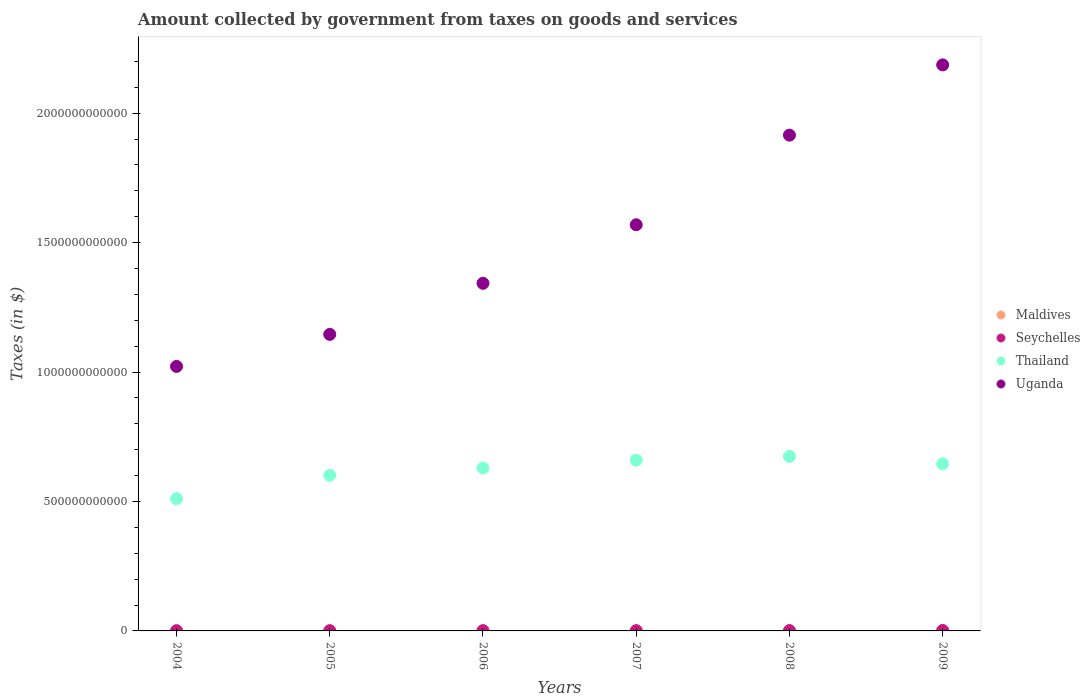Is the number of dotlines equal to the number of legend labels?
Your answer should be compact. Yes. What is the amount collected by government from taxes on goods and services in Seychelles in 2009?
Give a very brief answer. 1.66e+09. Across all years, what is the maximum amount collected by government from taxes on goods and services in Uganda?
Keep it short and to the point. 2.19e+12. Across all years, what is the minimum amount collected by government from taxes on goods and services in Uganda?
Offer a terse response. 1.02e+12. In which year was the amount collected by government from taxes on goods and services in Seychelles maximum?
Offer a terse response. 2009. In which year was the amount collected by government from taxes on goods and services in Seychelles minimum?
Offer a terse response. 2004. What is the total amount collected by government from taxes on goods and services in Uganda in the graph?
Provide a short and direct response. 9.18e+12. What is the difference between the amount collected by government from taxes on goods and services in Maldives in 2004 and that in 2008?
Keep it short and to the point. -1.87e+08. What is the difference between the amount collected by government from taxes on goods and services in Uganda in 2006 and the amount collected by government from taxes on goods and services in Thailand in 2009?
Offer a terse response. 6.97e+11. What is the average amount collected by government from taxes on goods and services in Uganda per year?
Offer a terse response. 1.53e+12. In the year 2006, what is the difference between the amount collected by government from taxes on goods and services in Seychelles and amount collected by government from taxes on goods and services in Thailand?
Offer a terse response. -6.29e+11. What is the ratio of the amount collected by government from taxes on goods and services in Maldives in 2005 to that in 2008?
Your answer should be very brief. 0.61. Is the amount collected by government from taxes on goods and services in Maldives in 2006 less than that in 2009?
Your answer should be compact. Yes. Is the difference between the amount collected by government from taxes on goods and services in Seychelles in 2007 and 2008 greater than the difference between the amount collected by government from taxes on goods and services in Thailand in 2007 and 2008?
Your answer should be very brief. Yes. What is the difference between the highest and the second highest amount collected by government from taxes on goods and services in Uganda?
Offer a very short reply. 2.71e+11. What is the difference between the highest and the lowest amount collected by government from taxes on goods and services in Uganda?
Provide a succinct answer. 1.16e+12. In how many years, is the amount collected by government from taxes on goods and services in Maldives greater than the average amount collected by government from taxes on goods and services in Maldives taken over all years?
Your answer should be very brief. 4. Is the sum of the amount collected by government from taxes on goods and services in Thailand in 2005 and 2009 greater than the maximum amount collected by government from taxes on goods and services in Maldives across all years?
Your answer should be compact. Yes. Is it the case that in every year, the sum of the amount collected by government from taxes on goods and services in Thailand and amount collected by government from taxes on goods and services in Uganda  is greater than the sum of amount collected by government from taxes on goods and services in Maldives and amount collected by government from taxes on goods and services in Seychelles?
Provide a succinct answer. Yes. Does the amount collected by government from taxes on goods and services in Uganda monotonically increase over the years?
Your answer should be very brief. Yes. How many dotlines are there?
Keep it short and to the point. 4. How many years are there in the graph?
Ensure brevity in your answer.  6. What is the difference between two consecutive major ticks on the Y-axis?
Keep it short and to the point. 5.00e+11. Are the values on the major ticks of Y-axis written in scientific E-notation?
Keep it short and to the point. No. Does the graph contain grids?
Make the answer very short. No. Where does the legend appear in the graph?
Provide a succinct answer. Center right. How are the legend labels stacked?
Provide a short and direct response. Vertical. What is the title of the graph?
Your response must be concise. Amount collected by government from taxes on goods and services. What is the label or title of the X-axis?
Offer a terse response. Years. What is the label or title of the Y-axis?
Keep it short and to the point. Taxes (in $). What is the Taxes (in $) in Maldives in 2004?
Make the answer very short. 4.50e+08. What is the Taxes (in $) in Seychelles in 2004?
Offer a terse response. 6.87e+08. What is the Taxes (in $) of Thailand in 2004?
Give a very brief answer. 5.11e+11. What is the Taxes (in $) in Uganda in 2004?
Ensure brevity in your answer.  1.02e+12. What is the Taxes (in $) in Maldives in 2005?
Provide a succinct answer. 3.91e+08. What is the Taxes (in $) of Seychelles in 2005?
Ensure brevity in your answer.  7.52e+08. What is the Taxes (in $) in Thailand in 2005?
Your answer should be very brief. 6.01e+11. What is the Taxes (in $) of Uganda in 2005?
Give a very brief answer. 1.15e+12. What is the Taxes (in $) in Maldives in 2006?
Provide a short and direct response. 5.49e+08. What is the Taxes (in $) of Seychelles in 2006?
Provide a short and direct response. 8.21e+08. What is the Taxes (in $) in Thailand in 2006?
Keep it short and to the point. 6.29e+11. What is the Taxes (in $) in Uganda in 2006?
Make the answer very short. 1.34e+12. What is the Taxes (in $) in Maldives in 2007?
Offer a very short reply. 6.08e+08. What is the Taxes (in $) in Seychelles in 2007?
Your response must be concise. 9.26e+08. What is the Taxes (in $) in Thailand in 2007?
Give a very brief answer. 6.60e+11. What is the Taxes (in $) in Uganda in 2007?
Offer a terse response. 1.57e+12. What is the Taxes (in $) in Maldives in 2008?
Provide a short and direct response. 6.38e+08. What is the Taxes (in $) of Seychelles in 2008?
Keep it short and to the point. 1.15e+09. What is the Taxes (in $) in Thailand in 2008?
Keep it short and to the point. 6.74e+11. What is the Taxes (in $) in Uganda in 2008?
Give a very brief answer. 1.92e+12. What is the Taxes (in $) in Maldives in 2009?
Your answer should be very brief. 6.10e+08. What is the Taxes (in $) in Seychelles in 2009?
Keep it short and to the point. 1.66e+09. What is the Taxes (in $) in Thailand in 2009?
Your answer should be very brief. 6.45e+11. What is the Taxes (in $) of Uganda in 2009?
Make the answer very short. 2.19e+12. Across all years, what is the maximum Taxes (in $) in Maldives?
Your answer should be compact. 6.38e+08. Across all years, what is the maximum Taxes (in $) of Seychelles?
Make the answer very short. 1.66e+09. Across all years, what is the maximum Taxes (in $) of Thailand?
Provide a short and direct response. 6.74e+11. Across all years, what is the maximum Taxes (in $) of Uganda?
Make the answer very short. 2.19e+12. Across all years, what is the minimum Taxes (in $) of Maldives?
Keep it short and to the point. 3.91e+08. Across all years, what is the minimum Taxes (in $) of Seychelles?
Offer a very short reply. 6.87e+08. Across all years, what is the minimum Taxes (in $) of Thailand?
Provide a short and direct response. 5.11e+11. Across all years, what is the minimum Taxes (in $) in Uganda?
Provide a short and direct response. 1.02e+12. What is the total Taxes (in $) of Maldives in the graph?
Offer a very short reply. 3.25e+09. What is the total Taxes (in $) in Seychelles in the graph?
Provide a short and direct response. 5.99e+09. What is the total Taxes (in $) of Thailand in the graph?
Make the answer very short. 3.72e+12. What is the total Taxes (in $) of Uganda in the graph?
Offer a very short reply. 9.18e+12. What is the difference between the Taxes (in $) of Maldives in 2004 and that in 2005?
Keep it short and to the point. 5.93e+07. What is the difference between the Taxes (in $) of Seychelles in 2004 and that in 2005?
Your answer should be compact. -6.48e+07. What is the difference between the Taxes (in $) of Thailand in 2004 and that in 2005?
Provide a short and direct response. -9.03e+1. What is the difference between the Taxes (in $) of Uganda in 2004 and that in 2005?
Provide a short and direct response. -1.24e+11. What is the difference between the Taxes (in $) in Maldives in 2004 and that in 2006?
Make the answer very short. -9.89e+07. What is the difference between the Taxes (in $) in Seychelles in 2004 and that in 2006?
Provide a short and direct response. -1.34e+08. What is the difference between the Taxes (in $) of Thailand in 2004 and that in 2006?
Ensure brevity in your answer.  -1.19e+11. What is the difference between the Taxes (in $) of Uganda in 2004 and that in 2006?
Your answer should be very brief. -3.21e+11. What is the difference between the Taxes (in $) in Maldives in 2004 and that in 2007?
Your response must be concise. -1.57e+08. What is the difference between the Taxes (in $) in Seychelles in 2004 and that in 2007?
Ensure brevity in your answer.  -2.40e+08. What is the difference between the Taxes (in $) in Thailand in 2004 and that in 2007?
Give a very brief answer. -1.49e+11. What is the difference between the Taxes (in $) of Uganda in 2004 and that in 2007?
Offer a terse response. -5.47e+11. What is the difference between the Taxes (in $) of Maldives in 2004 and that in 2008?
Offer a terse response. -1.87e+08. What is the difference between the Taxes (in $) in Seychelles in 2004 and that in 2008?
Provide a short and direct response. -4.60e+08. What is the difference between the Taxes (in $) of Thailand in 2004 and that in 2008?
Provide a succinct answer. -1.63e+11. What is the difference between the Taxes (in $) in Uganda in 2004 and that in 2008?
Your response must be concise. -8.93e+11. What is the difference between the Taxes (in $) of Maldives in 2004 and that in 2009?
Your answer should be compact. -1.60e+08. What is the difference between the Taxes (in $) in Seychelles in 2004 and that in 2009?
Offer a very short reply. -9.73e+08. What is the difference between the Taxes (in $) of Thailand in 2004 and that in 2009?
Offer a very short reply. -1.35e+11. What is the difference between the Taxes (in $) in Uganda in 2004 and that in 2009?
Provide a succinct answer. -1.16e+12. What is the difference between the Taxes (in $) in Maldives in 2005 and that in 2006?
Offer a very short reply. -1.58e+08. What is the difference between the Taxes (in $) of Seychelles in 2005 and that in 2006?
Give a very brief answer. -6.91e+07. What is the difference between the Taxes (in $) of Thailand in 2005 and that in 2006?
Your answer should be compact. -2.83e+1. What is the difference between the Taxes (in $) in Uganda in 2005 and that in 2006?
Make the answer very short. -1.97e+11. What is the difference between the Taxes (in $) of Maldives in 2005 and that in 2007?
Provide a short and direct response. -2.17e+08. What is the difference between the Taxes (in $) of Seychelles in 2005 and that in 2007?
Give a very brief answer. -1.75e+08. What is the difference between the Taxes (in $) in Thailand in 2005 and that in 2007?
Your response must be concise. -5.86e+1. What is the difference between the Taxes (in $) in Uganda in 2005 and that in 2007?
Make the answer very short. -4.23e+11. What is the difference between the Taxes (in $) of Maldives in 2005 and that in 2008?
Provide a short and direct response. -2.46e+08. What is the difference between the Taxes (in $) of Seychelles in 2005 and that in 2008?
Provide a short and direct response. -3.95e+08. What is the difference between the Taxes (in $) of Thailand in 2005 and that in 2008?
Your answer should be very brief. -7.30e+1. What is the difference between the Taxes (in $) in Uganda in 2005 and that in 2008?
Your response must be concise. -7.70e+11. What is the difference between the Taxes (in $) in Maldives in 2005 and that in 2009?
Your answer should be compact. -2.19e+08. What is the difference between the Taxes (in $) in Seychelles in 2005 and that in 2009?
Provide a short and direct response. -9.08e+08. What is the difference between the Taxes (in $) of Thailand in 2005 and that in 2009?
Your answer should be compact. -4.43e+1. What is the difference between the Taxes (in $) in Uganda in 2005 and that in 2009?
Ensure brevity in your answer.  -1.04e+12. What is the difference between the Taxes (in $) of Maldives in 2006 and that in 2007?
Give a very brief answer. -5.84e+07. What is the difference between the Taxes (in $) of Seychelles in 2006 and that in 2007?
Give a very brief answer. -1.06e+08. What is the difference between the Taxes (in $) of Thailand in 2006 and that in 2007?
Your answer should be very brief. -3.03e+1. What is the difference between the Taxes (in $) in Uganda in 2006 and that in 2007?
Provide a short and direct response. -2.26e+11. What is the difference between the Taxes (in $) of Maldives in 2006 and that in 2008?
Provide a short and direct response. -8.81e+07. What is the difference between the Taxes (in $) of Seychelles in 2006 and that in 2008?
Keep it short and to the point. -3.26e+08. What is the difference between the Taxes (in $) in Thailand in 2006 and that in 2008?
Your answer should be very brief. -4.47e+1. What is the difference between the Taxes (in $) of Uganda in 2006 and that in 2008?
Provide a short and direct response. -5.72e+11. What is the difference between the Taxes (in $) of Maldives in 2006 and that in 2009?
Offer a very short reply. -6.10e+07. What is the difference between the Taxes (in $) in Seychelles in 2006 and that in 2009?
Give a very brief answer. -8.39e+08. What is the difference between the Taxes (in $) of Thailand in 2006 and that in 2009?
Your answer should be very brief. -1.60e+1. What is the difference between the Taxes (in $) in Uganda in 2006 and that in 2009?
Provide a succinct answer. -8.44e+11. What is the difference between the Taxes (in $) in Maldives in 2007 and that in 2008?
Provide a succinct answer. -2.97e+07. What is the difference between the Taxes (in $) of Seychelles in 2007 and that in 2008?
Provide a succinct answer. -2.20e+08. What is the difference between the Taxes (in $) in Thailand in 2007 and that in 2008?
Provide a short and direct response. -1.44e+1. What is the difference between the Taxes (in $) of Uganda in 2007 and that in 2008?
Make the answer very short. -3.46e+11. What is the difference between the Taxes (in $) of Maldives in 2007 and that in 2009?
Your response must be concise. -2.60e+06. What is the difference between the Taxes (in $) of Seychelles in 2007 and that in 2009?
Give a very brief answer. -7.33e+08. What is the difference between the Taxes (in $) in Thailand in 2007 and that in 2009?
Your answer should be very brief. 1.43e+1. What is the difference between the Taxes (in $) in Uganda in 2007 and that in 2009?
Provide a short and direct response. -6.18e+11. What is the difference between the Taxes (in $) of Maldives in 2008 and that in 2009?
Ensure brevity in your answer.  2.71e+07. What is the difference between the Taxes (in $) in Seychelles in 2008 and that in 2009?
Provide a succinct answer. -5.13e+08. What is the difference between the Taxes (in $) of Thailand in 2008 and that in 2009?
Provide a short and direct response. 2.87e+1. What is the difference between the Taxes (in $) of Uganda in 2008 and that in 2009?
Keep it short and to the point. -2.71e+11. What is the difference between the Taxes (in $) in Maldives in 2004 and the Taxes (in $) in Seychelles in 2005?
Provide a short and direct response. -3.01e+08. What is the difference between the Taxes (in $) of Maldives in 2004 and the Taxes (in $) of Thailand in 2005?
Give a very brief answer. -6.01e+11. What is the difference between the Taxes (in $) of Maldives in 2004 and the Taxes (in $) of Uganda in 2005?
Provide a succinct answer. -1.15e+12. What is the difference between the Taxes (in $) in Seychelles in 2004 and the Taxes (in $) in Thailand in 2005?
Make the answer very short. -6.00e+11. What is the difference between the Taxes (in $) of Seychelles in 2004 and the Taxes (in $) of Uganda in 2005?
Provide a short and direct response. -1.14e+12. What is the difference between the Taxes (in $) of Thailand in 2004 and the Taxes (in $) of Uganda in 2005?
Provide a succinct answer. -6.35e+11. What is the difference between the Taxes (in $) in Maldives in 2004 and the Taxes (in $) in Seychelles in 2006?
Your response must be concise. -3.70e+08. What is the difference between the Taxes (in $) of Maldives in 2004 and the Taxes (in $) of Thailand in 2006?
Make the answer very short. -6.29e+11. What is the difference between the Taxes (in $) in Maldives in 2004 and the Taxes (in $) in Uganda in 2006?
Make the answer very short. -1.34e+12. What is the difference between the Taxes (in $) of Seychelles in 2004 and the Taxes (in $) of Thailand in 2006?
Ensure brevity in your answer.  -6.29e+11. What is the difference between the Taxes (in $) in Seychelles in 2004 and the Taxes (in $) in Uganda in 2006?
Provide a succinct answer. -1.34e+12. What is the difference between the Taxes (in $) in Thailand in 2004 and the Taxes (in $) in Uganda in 2006?
Offer a terse response. -8.32e+11. What is the difference between the Taxes (in $) of Maldives in 2004 and the Taxes (in $) of Seychelles in 2007?
Offer a very short reply. -4.76e+08. What is the difference between the Taxes (in $) in Maldives in 2004 and the Taxes (in $) in Thailand in 2007?
Provide a short and direct response. -6.59e+11. What is the difference between the Taxes (in $) of Maldives in 2004 and the Taxes (in $) of Uganda in 2007?
Give a very brief answer. -1.57e+12. What is the difference between the Taxes (in $) of Seychelles in 2004 and the Taxes (in $) of Thailand in 2007?
Give a very brief answer. -6.59e+11. What is the difference between the Taxes (in $) in Seychelles in 2004 and the Taxes (in $) in Uganda in 2007?
Your answer should be very brief. -1.57e+12. What is the difference between the Taxes (in $) of Thailand in 2004 and the Taxes (in $) of Uganda in 2007?
Your answer should be very brief. -1.06e+12. What is the difference between the Taxes (in $) of Maldives in 2004 and the Taxes (in $) of Seychelles in 2008?
Ensure brevity in your answer.  -6.96e+08. What is the difference between the Taxes (in $) in Maldives in 2004 and the Taxes (in $) in Thailand in 2008?
Make the answer very short. -6.74e+11. What is the difference between the Taxes (in $) of Maldives in 2004 and the Taxes (in $) of Uganda in 2008?
Provide a succinct answer. -1.91e+12. What is the difference between the Taxes (in $) of Seychelles in 2004 and the Taxes (in $) of Thailand in 2008?
Offer a terse response. -6.73e+11. What is the difference between the Taxes (in $) of Seychelles in 2004 and the Taxes (in $) of Uganda in 2008?
Keep it short and to the point. -1.91e+12. What is the difference between the Taxes (in $) of Thailand in 2004 and the Taxes (in $) of Uganda in 2008?
Give a very brief answer. -1.40e+12. What is the difference between the Taxes (in $) in Maldives in 2004 and the Taxes (in $) in Seychelles in 2009?
Your answer should be compact. -1.21e+09. What is the difference between the Taxes (in $) of Maldives in 2004 and the Taxes (in $) of Thailand in 2009?
Provide a succinct answer. -6.45e+11. What is the difference between the Taxes (in $) of Maldives in 2004 and the Taxes (in $) of Uganda in 2009?
Offer a terse response. -2.19e+12. What is the difference between the Taxes (in $) of Seychelles in 2004 and the Taxes (in $) of Thailand in 2009?
Offer a very short reply. -6.45e+11. What is the difference between the Taxes (in $) of Seychelles in 2004 and the Taxes (in $) of Uganda in 2009?
Give a very brief answer. -2.19e+12. What is the difference between the Taxes (in $) of Thailand in 2004 and the Taxes (in $) of Uganda in 2009?
Give a very brief answer. -1.68e+12. What is the difference between the Taxes (in $) of Maldives in 2005 and the Taxes (in $) of Seychelles in 2006?
Provide a short and direct response. -4.29e+08. What is the difference between the Taxes (in $) in Maldives in 2005 and the Taxes (in $) in Thailand in 2006?
Offer a terse response. -6.29e+11. What is the difference between the Taxes (in $) of Maldives in 2005 and the Taxes (in $) of Uganda in 2006?
Provide a succinct answer. -1.34e+12. What is the difference between the Taxes (in $) of Seychelles in 2005 and the Taxes (in $) of Thailand in 2006?
Your answer should be very brief. -6.29e+11. What is the difference between the Taxes (in $) in Seychelles in 2005 and the Taxes (in $) in Uganda in 2006?
Your answer should be very brief. -1.34e+12. What is the difference between the Taxes (in $) of Thailand in 2005 and the Taxes (in $) of Uganda in 2006?
Ensure brevity in your answer.  -7.42e+11. What is the difference between the Taxes (in $) of Maldives in 2005 and the Taxes (in $) of Seychelles in 2007?
Offer a very short reply. -5.35e+08. What is the difference between the Taxes (in $) in Maldives in 2005 and the Taxes (in $) in Thailand in 2007?
Offer a terse response. -6.59e+11. What is the difference between the Taxes (in $) of Maldives in 2005 and the Taxes (in $) of Uganda in 2007?
Your response must be concise. -1.57e+12. What is the difference between the Taxes (in $) of Seychelles in 2005 and the Taxes (in $) of Thailand in 2007?
Make the answer very short. -6.59e+11. What is the difference between the Taxes (in $) of Seychelles in 2005 and the Taxes (in $) of Uganda in 2007?
Keep it short and to the point. -1.57e+12. What is the difference between the Taxes (in $) in Thailand in 2005 and the Taxes (in $) in Uganda in 2007?
Your answer should be compact. -9.68e+11. What is the difference between the Taxes (in $) of Maldives in 2005 and the Taxes (in $) of Seychelles in 2008?
Provide a succinct answer. -7.55e+08. What is the difference between the Taxes (in $) of Maldives in 2005 and the Taxes (in $) of Thailand in 2008?
Offer a terse response. -6.74e+11. What is the difference between the Taxes (in $) of Maldives in 2005 and the Taxes (in $) of Uganda in 2008?
Your response must be concise. -1.91e+12. What is the difference between the Taxes (in $) of Seychelles in 2005 and the Taxes (in $) of Thailand in 2008?
Your response must be concise. -6.73e+11. What is the difference between the Taxes (in $) in Seychelles in 2005 and the Taxes (in $) in Uganda in 2008?
Your response must be concise. -1.91e+12. What is the difference between the Taxes (in $) of Thailand in 2005 and the Taxes (in $) of Uganda in 2008?
Provide a succinct answer. -1.31e+12. What is the difference between the Taxes (in $) of Maldives in 2005 and the Taxes (in $) of Seychelles in 2009?
Your answer should be compact. -1.27e+09. What is the difference between the Taxes (in $) of Maldives in 2005 and the Taxes (in $) of Thailand in 2009?
Your response must be concise. -6.45e+11. What is the difference between the Taxes (in $) in Maldives in 2005 and the Taxes (in $) in Uganda in 2009?
Your answer should be compact. -2.19e+12. What is the difference between the Taxes (in $) in Seychelles in 2005 and the Taxes (in $) in Thailand in 2009?
Offer a terse response. -6.45e+11. What is the difference between the Taxes (in $) in Seychelles in 2005 and the Taxes (in $) in Uganda in 2009?
Offer a terse response. -2.19e+12. What is the difference between the Taxes (in $) of Thailand in 2005 and the Taxes (in $) of Uganda in 2009?
Provide a succinct answer. -1.59e+12. What is the difference between the Taxes (in $) in Maldives in 2006 and the Taxes (in $) in Seychelles in 2007?
Provide a short and direct response. -3.77e+08. What is the difference between the Taxes (in $) in Maldives in 2006 and the Taxes (in $) in Thailand in 2007?
Your answer should be very brief. -6.59e+11. What is the difference between the Taxes (in $) of Maldives in 2006 and the Taxes (in $) of Uganda in 2007?
Your answer should be very brief. -1.57e+12. What is the difference between the Taxes (in $) in Seychelles in 2006 and the Taxes (in $) in Thailand in 2007?
Your response must be concise. -6.59e+11. What is the difference between the Taxes (in $) in Seychelles in 2006 and the Taxes (in $) in Uganda in 2007?
Your response must be concise. -1.57e+12. What is the difference between the Taxes (in $) of Thailand in 2006 and the Taxes (in $) of Uganda in 2007?
Your response must be concise. -9.40e+11. What is the difference between the Taxes (in $) in Maldives in 2006 and the Taxes (in $) in Seychelles in 2008?
Your answer should be compact. -5.97e+08. What is the difference between the Taxes (in $) in Maldives in 2006 and the Taxes (in $) in Thailand in 2008?
Give a very brief answer. -6.74e+11. What is the difference between the Taxes (in $) in Maldives in 2006 and the Taxes (in $) in Uganda in 2008?
Give a very brief answer. -1.91e+12. What is the difference between the Taxes (in $) in Seychelles in 2006 and the Taxes (in $) in Thailand in 2008?
Your response must be concise. -6.73e+11. What is the difference between the Taxes (in $) of Seychelles in 2006 and the Taxes (in $) of Uganda in 2008?
Your response must be concise. -1.91e+12. What is the difference between the Taxes (in $) of Thailand in 2006 and the Taxes (in $) of Uganda in 2008?
Give a very brief answer. -1.29e+12. What is the difference between the Taxes (in $) in Maldives in 2006 and the Taxes (in $) in Seychelles in 2009?
Your answer should be very brief. -1.11e+09. What is the difference between the Taxes (in $) of Maldives in 2006 and the Taxes (in $) of Thailand in 2009?
Offer a very short reply. -6.45e+11. What is the difference between the Taxes (in $) of Maldives in 2006 and the Taxes (in $) of Uganda in 2009?
Keep it short and to the point. -2.19e+12. What is the difference between the Taxes (in $) of Seychelles in 2006 and the Taxes (in $) of Thailand in 2009?
Offer a terse response. -6.45e+11. What is the difference between the Taxes (in $) in Seychelles in 2006 and the Taxes (in $) in Uganda in 2009?
Offer a terse response. -2.19e+12. What is the difference between the Taxes (in $) in Thailand in 2006 and the Taxes (in $) in Uganda in 2009?
Provide a succinct answer. -1.56e+12. What is the difference between the Taxes (in $) in Maldives in 2007 and the Taxes (in $) in Seychelles in 2008?
Keep it short and to the point. -5.39e+08. What is the difference between the Taxes (in $) in Maldives in 2007 and the Taxes (in $) in Thailand in 2008?
Provide a short and direct response. -6.73e+11. What is the difference between the Taxes (in $) in Maldives in 2007 and the Taxes (in $) in Uganda in 2008?
Offer a terse response. -1.91e+12. What is the difference between the Taxes (in $) of Seychelles in 2007 and the Taxes (in $) of Thailand in 2008?
Your answer should be very brief. -6.73e+11. What is the difference between the Taxes (in $) in Seychelles in 2007 and the Taxes (in $) in Uganda in 2008?
Keep it short and to the point. -1.91e+12. What is the difference between the Taxes (in $) of Thailand in 2007 and the Taxes (in $) of Uganda in 2008?
Make the answer very short. -1.26e+12. What is the difference between the Taxes (in $) in Maldives in 2007 and the Taxes (in $) in Seychelles in 2009?
Your answer should be very brief. -1.05e+09. What is the difference between the Taxes (in $) of Maldives in 2007 and the Taxes (in $) of Thailand in 2009?
Your answer should be compact. -6.45e+11. What is the difference between the Taxes (in $) of Maldives in 2007 and the Taxes (in $) of Uganda in 2009?
Keep it short and to the point. -2.19e+12. What is the difference between the Taxes (in $) in Seychelles in 2007 and the Taxes (in $) in Thailand in 2009?
Your response must be concise. -6.44e+11. What is the difference between the Taxes (in $) in Seychelles in 2007 and the Taxes (in $) in Uganda in 2009?
Offer a very short reply. -2.19e+12. What is the difference between the Taxes (in $) of Thailand in 2007 and the Taxes (in $) of Uganda in 2009?
Provide a succinct answer. -1.53e+12. What is the difference between the Taxes (in $) of Maldives in 2008 and the Taxes (in $) of Seychelles in 2009?
Provide a succinct answer. -1.02e+09. What is the difference between the Taxes (in $) in Maldives in 2008 and the Taxes (in $) in Thailand in 2009?
Offer a terse response. -6.45e+11. What is the difference between the Taxes (in $) of Maldives in 2008 and the Taxes (in $) of Uganda in 2009?
Offer a very short reply. -2.19e+12. What is the difference between the Taxes (in $) of Seychelles in 2008 and the Taxes (in $) of Thailand in 2009?
Make the answer very short. -6.44e+11. What is the difference between the Taxes (in $) of Seychelles in 2008 and the Taxes (in $) of Uganda in 2009?
Provide a short and direct response. -2.19e+12. What is the difference between the Taxes (in $) in Thailand in 2008 and the Taxes (in $) in Uganda in 2009?
Your answer should be compact. -1.51e+12. What is the average Taxes (in $) of Maldives per year?
Keep it short and to the point. 5.41e+08. What is the average Taxes (in $) in Seychelles per year?
Give a very brief answer. 9.99e+08. What is the average Taxes (in $) in Thailand per year?
Your answer should be very brief. 6.20e+11. What is the average Taxes (in $) in Uganda per year?
Provide a short and direct response. 1.53e+12. In the year 2004, what is the difference between the Taxes (in $) in Maldives and Taxes (in $) in Seychelles?
Provide a short and direct response. -2.36e+08. In the year 2004, what is the difference between the Taxes (in $) of Maldives and Taxes (in $) of Thailand?
Ensure brevity in your answer.  -5.10e+11. In the year 2004, what is the difference between the Taxes (in $) in Maldives and Taxes (in $) in Uganda?
Provide a succinct answer. -1.02e+12. In the year 2004, what is the difference between the Taxes (in $) of Seychelles and Taxes (in $) of Thailand?
Offer a very short reply. -5.10e+11. In the year 2004, what is the difference between the Taxes (in $) in Seychelles and Taxes (in $) in Uganda?
Provide a succinct answer. -1.02e+12. In the year 2004, what is the difference between the Taxes (in $) in Thailand and Taxes (in $) in Uganda?
Your answer should be compact. -5.11e+11. In the year 2005, what is the difference between the Taxes (in $) in Maldives and Taxes (in $) in Seychelles?
Ensure brevity in your answer.  -3.60e+08. In the year 2005, what is the difference between the Taxes (in $) of Maldives and Taxes (in $) of Thailand?
Keep it short and to the point. -6.01e+11. In the year 2005, what is the difference between the Taxes (in $) in Maldives and Taxes (in $) in Uganda?
Ensure brevity in your answer.  -1.15e+12. In the year 2005, what is the difference between the Taxes (in $) in Seychelles and Taxes (in $) in Thailand?
Make the answer very short. -6.00e+11. In the year 2005, what is the difference between the Taxes (in $) of Seychelles and Taxes (in $) of Uganda?
Keep it short and to the point. -1.14e+12. In the year 2005, what is the difference between the Taxes (in $) of Thailand and Taxes (in $) of Uganda?
Offer a very short reply. -5.44e+11. In the year 2006, what is the difference between the Taxes (in $) in Maldives and Taxes (in $) in Seychelles?
Offer a terse response. -2.71e+08. In the year 2006, what is the difference between the Taxes (in $) in Maldives and Taxes (in $) in Thailand?
Provide a succinct answer. -6.29e+11. In the year 2006, what is the difference between the Taxes (in $) in Maldives and Taxes (in $) in Uganda?
Give a very brief answer. -1.34e+12. In the year 2006, what is the difference between the Taxes (in $) in Seychelles and Taxes (in $) in Thailand?
Your answer should be very brief. -6.29e+11. In the year 2006, what is the difference between the Taxes (in $) in Seychelles and Taxes (in $) in Uganda?
Your answer should be compact. -1.34e+12. In the year 2006, what is the difference between the Taxes (in $) in Thailand and Taxes (in $) in Uganda?
Make the answer very short. -7.13e+11. In the year 2007, what is the difference between the Taxes (in $) in Maldives and Taxes (in $) in Seychelles?
Your answer should be compact. -3.19e+08. In the year 2007, what is the difference between the Taxes (in $) of Maldives and Taxes (in $) of Thailand?
Provide a succinct answer. -6.59e+11. In the year 2007, what is the difference between the Taxes (in $) in Maldives and Taxes (in $) in Uganda?
Provide a succinct answer. -1.57e+12. In the year 2007, what is the difference between the Taxes (in $) of Seychelles and Taxes (in $) of Thailand?
Ensure brevity in your answer.  -6.59e+11. In the year 2007, what is the difference between the Taxes (in $) of Seychelles and Taxes (in $) of Uganda?
Provide a succinct answer. -1.57e+12. In the year 2007, what is the difference between the Taxes (in $) in Thailand and Taxes (in $) in Uganda?
Keep it short and to the point. -9.09e+11. In the year 2008, what is the difference between the Taxes (in $) in Maldives and Taxes (in $) in Seychelles?
Your answer should be very brief. -5.09e+08. In the year 2008, what is the difference between the Taxes (in $) in Maldives and Taxes (in $) in Thailand?
Keep it short and to the point. -6.73e+11. In the year 2008, what is the difference between the Taxes (in $) of Maldives and Taxes (in $) of Uganda?
Give a very brief answer. -1.91e+12. In the year 2008, what is the difference between the Taxes (in $) in Seychelles and Taxes (in $) in Thailand?
Offer a very short reply. -6.73e+11. In the year 2008, what is the difference between the Taxes (in $) in Seychelles and Taxes (in $) in Uganda?
Make the answer very short. -1.91e+12. In the year 2008, what is the difference between the Taxes (in $) of Thailand and Taxes (in $) of Uganda?
Provide a short and direct response. -1.24e+12. In the year 2009, what is the difference between the Taxes (in $) of Maldives and Taxes (in $) of Seychelles?
Give a very brief answer. -1.05e+09. In the year 2009, what is the difference between the Taxes (in $) of Maldives and Taxes (in $) of Thailand?
Your answer should be very brief. -6.45e+11. In the year 2009, what is the difference between the Taxes (in $) of Maldives and Taxes (in $) of Uganda?
Your response must be concise. -2.19e+12. In the year 2009, what is the difference between the Taxes (in $) in Seychelles and Taxes (in $) in Thailand?
Make the answer very short. -6.44e+11. In the year 2009, what is the difference between the Taxes (in $) of Seychelles and Taxes (in $) of Uganda?
Provide a short and direct response. -2.18e+12. In the year 2009, what is the difference between the Taxes (in $) of Thailand and Taxes (in $) of Uganda?
Provide a succinct answer. -1.54e+12. What is the ratio of the Taxes (in $) in Maldives in 2004 to that in 2005?
Your response must be concise. 1.15. What is the ratio of the Taxes (in $) in Seychelles in 2004 to that in 2005?
Give a very brief answer. 0.91. What is the ratio of the Taxes (in $) of Thailand in 2004 to that in 2005?
Offer a very short reply. 0.85. What is the ratio of the Taxes (in $) of Uganda in 2004 to that in 2005?
Provide a short and direct response. 0.89. What is the ratio of the Taxes (in $) in Maldives in 2004 to that in 2006?
Give a very brief answer. 0.82. What is the ratio of the Taxes (in $) in Seychelles in 2004 to that in 2006?
Your answer should be very brief. 0.84. What is the ratio of the Taxes (in $) of Thailand in 2004 to that in 2006?
Your response must be concise. 0.81. What is the ratio of the Taxes (in $) of Uganda in 2004 to that in 2006?
Your response must be concise. 0.76. What is the ratio of the Taxes (in $) of Maldives in 2004 to that in 2007?
Offer a terse response. 0.74. What is the ratio of the Taxes (in $) of Seychelles in 2004 to that in 2007?
Offer a very short reply. 0.74. What is the ratio of the Taxes (in $) in Thailand in 2004 to that in 2007?
Offer a terse response. 0.77. What is the ratio of the Taxes (in $) in Uganda in 2004 to that in 2007?
Offer a very short reply. 0.65. What is the ratio of the Taxes (in $) in Maldives in 2004 to that in 2008?
Keep it short and to the point. 0.71. What is the ratio of the Taxes (in $) in Seychelles in 2004 to that in 2008?
Your response must be concise. 0.6. What is the ratio of the Taxes (in $) in Thailand in 2004 to that in 2008?
Provide a succinct answer. 0.76. What is the ratio of the Taxes (in $) of Uganda in 2004 to that in 2008?
Make the answer very short. 0.53. What is the ratio of the Taxes (in $) in Maldives in 2004 to that in 2009?
Keep it short and to the point. 0.74. What is the ratio of the Taxes (in $) of Seychelles in 2004 to that in 2009?
Ensure brevity in your answer.  0.41. What is the ratio of the Taxes (in $) in Thailand in 2004 to that in 2009?
Your answer should be compact. 0.79. What is the ratio of the Taxes (in $) in Uganda in 2004 to that in 2009?
Offer a very short reply. 0.47. What is the ratio of the Taxes (in $) of Maldives in 2005 to that in 2006?
Keep it short and to the point. 0.71. What is the ratio of the Taxes (in $) of Seychelles in 2005 to that in 2006?
Your response must be concise. 0.92. What is the ratio of the Taxes (in $) in Thailand in 2005 to that in 2006?
Give a very brief answer. 0.96. What is the ratio of the Taxes (in $) in Uganda in 2005 to that in 2006?
Keep it short and to the point. 0.85. What is the ratio of the Taxes (in $) of Maldives in 2005 to that in 2007?
Provide a succinct answer. 0.64. What is the ratio of the Taxes (in $) in Seychelles in 2005 to that in 2007?
Your answer should be very brief. 0.81. What is the ratio of the Taxes (in $) in Thailand in 2005 to that in 2007?
Offer a terse response. 0.91. What is the ratio of the Taxes (in $) in Uganda in 2005 to that in 2007?
Provide a short and direct response. 0.73. What is the ratio of the Taxes (in $) of Maldives in 2005 to that in 2008?
Offer a very short reply. 0.61. What is the ratio of the Taxes (in $) of Seychelles in 2005 to that in 2008?
Provide a short and direct response. 0.66. What is the ratio of the Taxes (in $) in Thailand in 2005 to that in 2008?
Your response must be concise. 0.89. What is the ratio of the Taxes (in $) of Uganda in 2005 to that in 2008?
Give a very brief answer. 0.6. What is the ratio of the Taxes (in $) of Maldives in 2005 to that in 2009?
Make the answer very short. 0.64. What is the ratio of the Taxes (in $) of Seychelles in 2005 to that in 2009?
Your answer should be very brief. 0.45. What is the ratio of the Taxes (in $) in Thailand in 2005 to that in 2009?
Your answer should be very brief. 0.93. What is the ratio of the Taxes (in $) of Uganda in 2005 to that in 2009?
Offer a terse response. 0.52. What is the ratio of the Taxes (in $) in Maldives in 2006 to that in 2007?
Make the answer very short. 0.9. What is the ratio of the Taxes (in $) in Seychelles in 2006 to that in 2007?
Give a very brief answer. 0.89. What is the ratio of the Taxes (in $) in Thailand in 2006 to that in 2007?
Provide a short and direct response. 0.95. What is the ratio of the Taxes (in $) of Uganda in 2006 to that in 2007?
Provide a short and direct response. 0.86. What is the ratio of the Taxes (in $) in Maldives in 2006 to that in 2008?
Your response must be concise. 0.86. What is the ratio of the Taxes (in $) in Seychelles in 2006 to that in 2008?
Your response must be concise. 0.72. What is the ratio of the Taxes (in $) in Thailand in 2006 to that in 2008?
Offer a very short reply. 0.93. What is the ratio of the Taxes (in $) in Uganda in 2006 to that in 2008?
Provide a short and direct response. 0.7. What is the ratio of the Taxes (in $) of Maldives in 2006 to that in 2009?
Provide a short and direct response. 0.9. What is the ratio of the Taxes (in $) of Seychelles in 2006 to that in 2009?
Offer a terse response. 0.49. What is the ratio of the Taxes (in $) in Thailand in 2006 to that in 2009?
Your answer should be very brief. 0.98. What is the ratio of the Taxes (in $) of Uganda in 2006 to that in 2009?
Offer a very short reply. 0.61. What is the ratio of the Taxes (in $) of Maldives in 2007 to that in 2008?
Offer a very short reply. 0.95. What is the ratio of the Taxes (in $) of Seychelles in 2007 to that in 2008?
Offer a terse response. 0.81. What is the ratio of the Taxes (in $) in Thailand in 2007 to that in 2008?
Offer a very short reply. 0.98. What is the ratio of the Taxes (in $) in Uganda in 2007 to that in 2008?
Ensure brevity in your answer.  0.82. What is the ratio of the Taxes (in $) in Seychelles in 2007 to that in 2009?
Provide a short and direct response. 0.56. What is the ratio of the Taxes (in $) in Thailand in 2007 to that in 2009?
Your answer should be compact. 1.02. What is the ratio of the Taxes (in $) in Uganda in 2007 to that in 2009?
Your answer should be compact. 0.72. What is the ratio of the Taxes (in $) in Maldives in 2008 to that in 2009?
Keep it short and to the point. 1.04. What is the ratio of the Taxes (in $) in Seychelles in 2008 to that in 2009?
Offer a very short reply. 0.69. What is the ratio of the Taxes (in $) of Thailand in 2008 to that in 2009?
Ensure brevity in your answer.  1.04. What is the ratio of the Taxes (in $) in Uganda in 2008 to that in 2009?
Offer a very short reply. 0.88. What is the difference between the highest and the second highest Taxes (in $) in Maldives?
Provide a short and direct response. 2.71e+07. What is the difference between the highest and the second highest Taxes (in $) of Seychelles?
Your answer should be compact. 5.13e+08. What is the difference between the highest and the second highest Taxes (in $) in Thailand?
Your answer should be compact. 1.44e+1. What is the difference between the highest and the second highest Taxes (in $) of Uganda?
Your answer should be very brief. 2.71e+11. What is the difference between the highest and the lowest Taxes (in $) of Maldives?
Make the answer very short. 2.46e+08. What is the difference between the highest and the lowest Taxes (in $) of Seychelles?
Ensure brevity in your answer.  9.73e+08. What is the difference between the highest and the lowest Taxes (in $) of Thailand?
Your response must be concise. 1.63e+11. What is the difference between the highest and the lowest Taxes (in $) in Uganda?
Keep it short and to the point. 1.16e+12. 